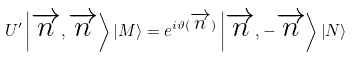<formula> <loc_0><loc_0><loc_500><loc_500>U ^ { \prime } \left | \overrightarrow { n } , \overrightarrow { n } \right \rangle \left | M \right \rangle = e ^ { i \vartheta ( \overrightarrow { n } ) } \left | \overrightarrow { n } , - \overrightarrow { n } \right \rangle \left | N \right \rangle</formula> 